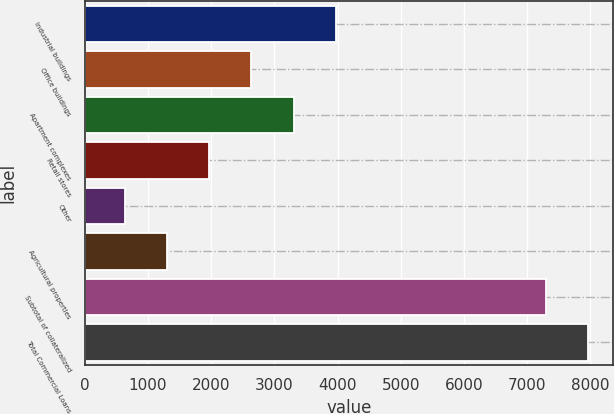<chart> <loc_0><loc_0><loc_500><loc_500><bar_chart><fcel>Industrial buildings<fcel>Office buildings<fcel>Apartment complexes<fcel>Retail stores<fcel>Other<fcel>Agricultural properties<fcel>Subtotal of collateralized<fcel>Total Commercial Loans<nl><fcel>3969<fcel>2636.6<fcel>3302.8<fcel>1970.4<fcel>638<fcel>1304.2<fcel>7300<fcel>7966.2<nl></chart> 